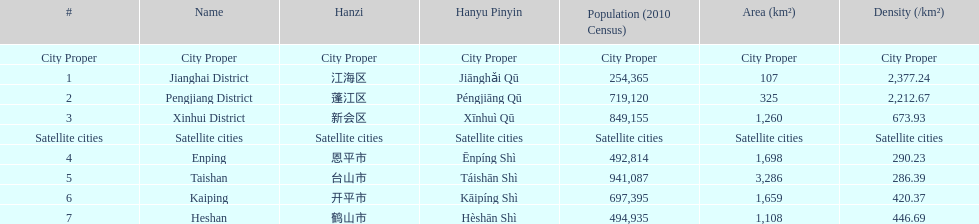Does enping have a higher/lower population density than kaiping? Less. 